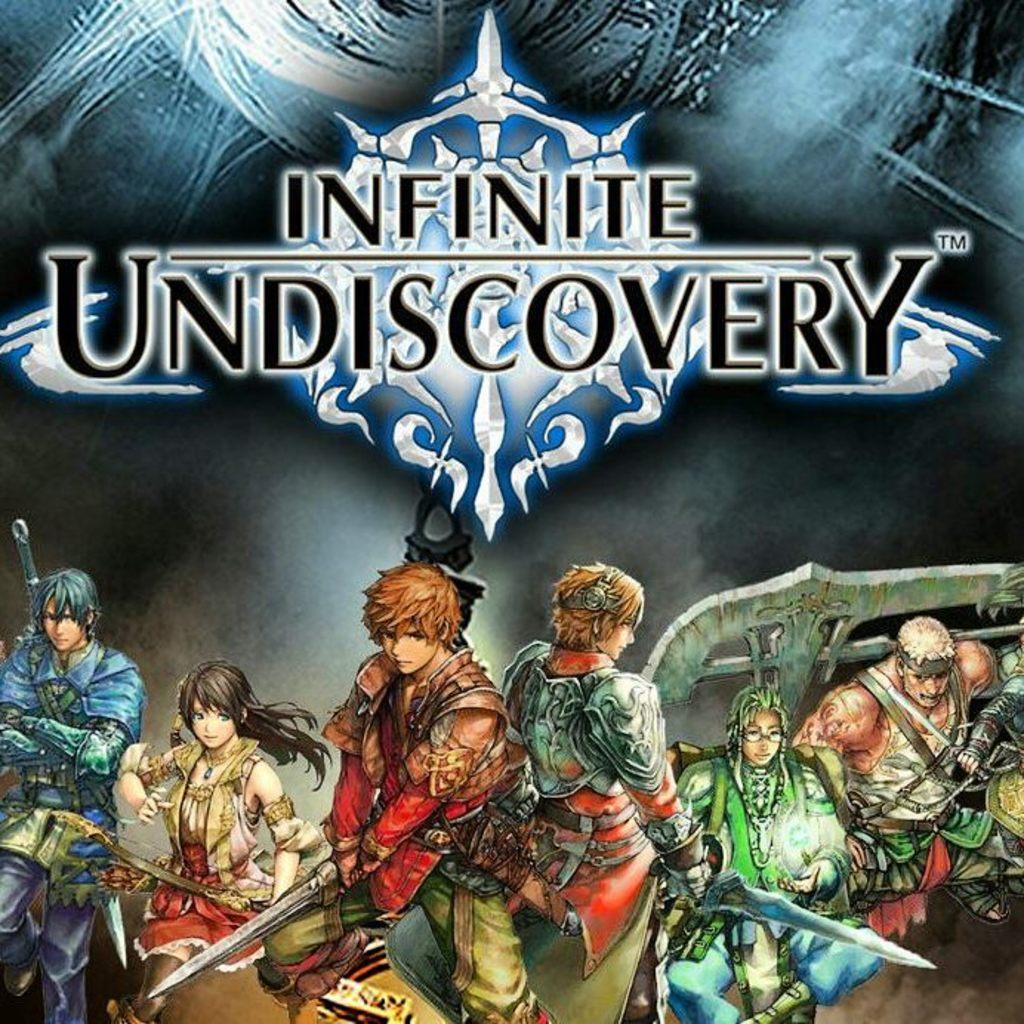What game is this?
Give a very brief answer. Infinite undiscovery. 